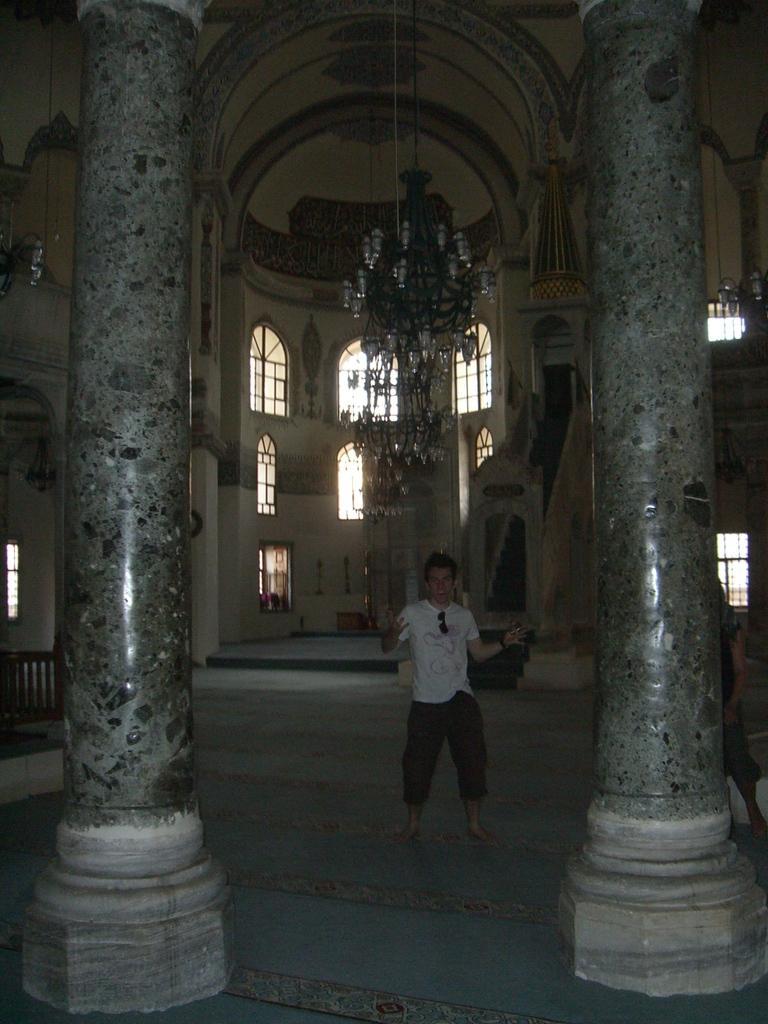Could you give a brief overview of what you see in this image? This image is taken from inside the building. In this image there is a person standing in between the pillars. In the background there are windows and a wall. At the top of the image there is a lamp hanging from the ceiling. 